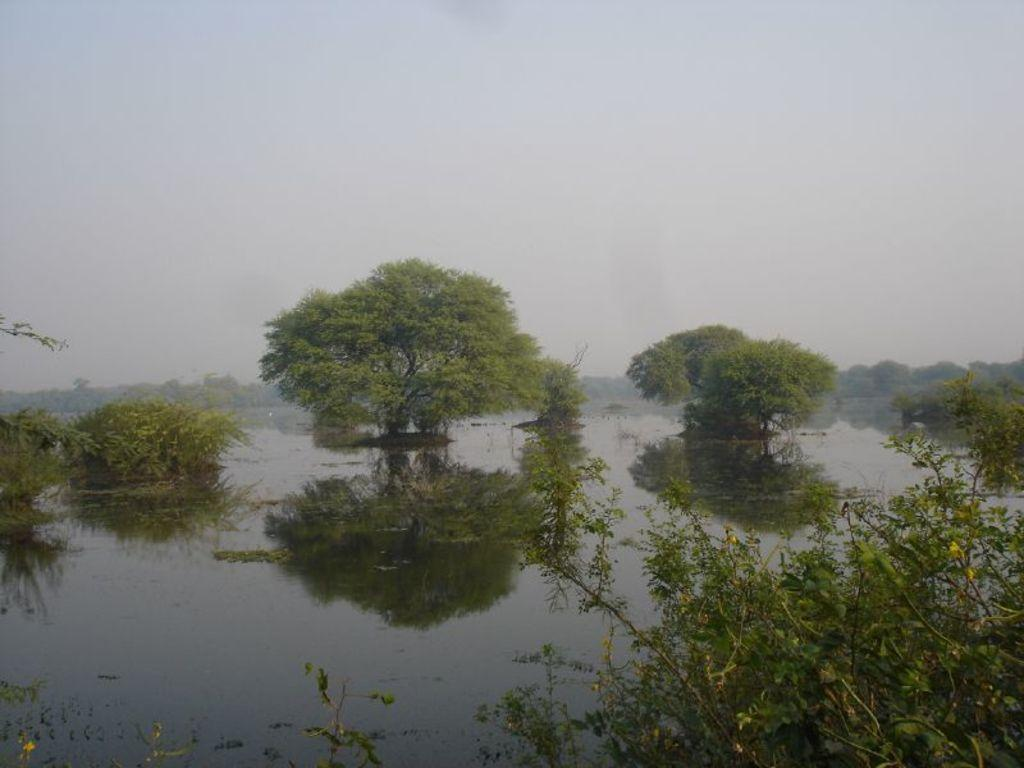What type of natural environment is depicted in the image? There are many trees and plants in the image, suggesting a forest or park setting. What is the reflection of in the water? The reflection of trees is visible on the water surface. What body of water is present in the image? There is a lake in the image. What can be seen above the trees and lake in the image? The sky is visible in the image. What language is being spoken by the trees in the image? Trees do not speak any language, so this cannot be determined from the image. 